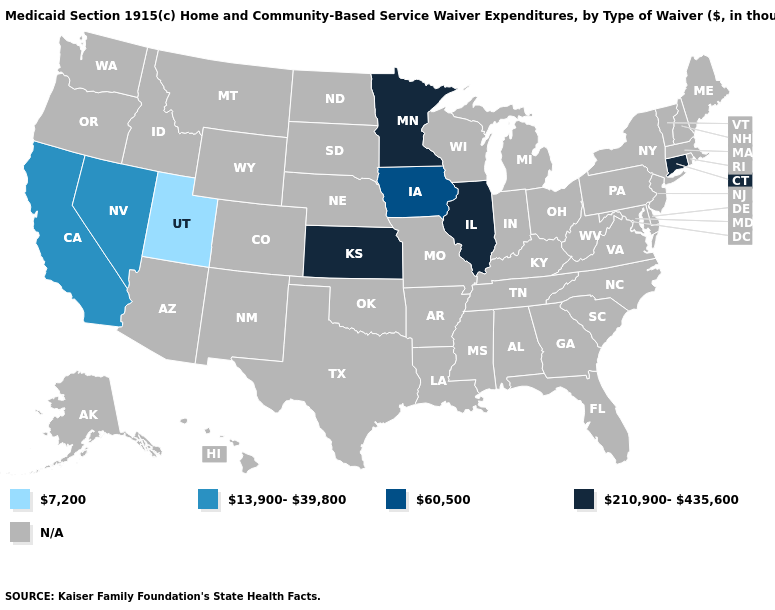Does California have the highest value in the West?
Be succinct. Yes. What is the value of Maine?
Concise answer only. N/A. Which states have the lowest value in the USA?
Write a very short answer. Utah. What is the lowest value in the Northeast?
Write a very short answer. 210,900-435,600. Name the states that have a value in the range N/A?
Be succinct. Alabama, Alaska, Arizona, Arkansas, Colorado, Delaware, Florida, Georgia, Hawaii, Idaho, Indiana, Kentucky, Louisiana, Maine, Maryland, Massachusetts, Michigan, Mississippi, Missouri, Montana, Nebraska, New Hampshire, New Jersey, New Mexico, New York, North Carolina, North Dakota, Ohio, Oklahoma, Oregon, Pennsylvania, Rhode Island, South Carolina, South Dakota, Tennessee, Texas, Vermont, Virginia, Washington, West Virginia, Wisconsin, Wyoming. Which states have the lowest value in the USA?
Concise answer only. Utah. Does Utah have the highest value in the USA?
Short answer required. No. Is the legend a continuous bar?
Be succinct. No. What is the value of Montana?
Keep it brief. N/A. Does California have the lowest value in the West?
Quick response, please. No. Is the legend a continuous bar?
Concise answer only. No. What is the value of Arizona?
Concise answer only. N/A. Name the states that have a value in the range 210,900-435,600?
Be succinct. Connecticut, Illinois, Kansas, Minnesota. 